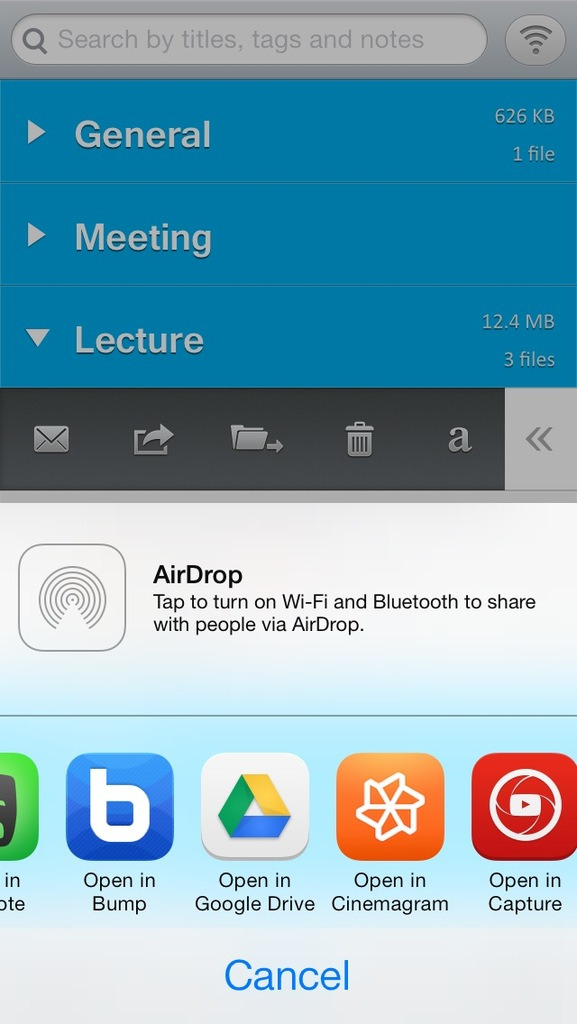Explain the significance of having both AirDrop and Google Drive as sharing options on this screen. Having both AirDrop and Google Drive as sharing options offers flexibility in file sharing; AirDrop allows for immediate, local transfers without the need for internet, while Google Drive provides a way to share files over the cloud, which can be accessed from any device with internet connectivity. 